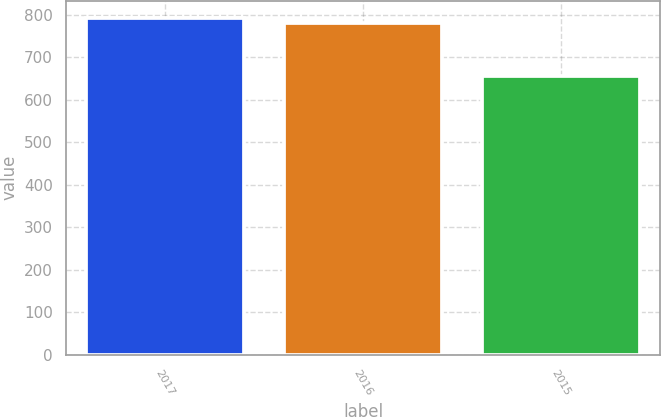Convert chart. <chart><loc_0><loc_0><loc_500><loc_500><bar_chart><fcel>2017<fcel>2016<fcel>2015<nl><fcel>793.7<fcel>781<fcel>657<nl></chart> 